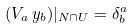<formula> <loc_0><loc_0><loc_500><loc_500>( V _ { a } \, y _ { b } ) | _ { N \cap U } = \delta ^ { a } _ { b }</formula> 